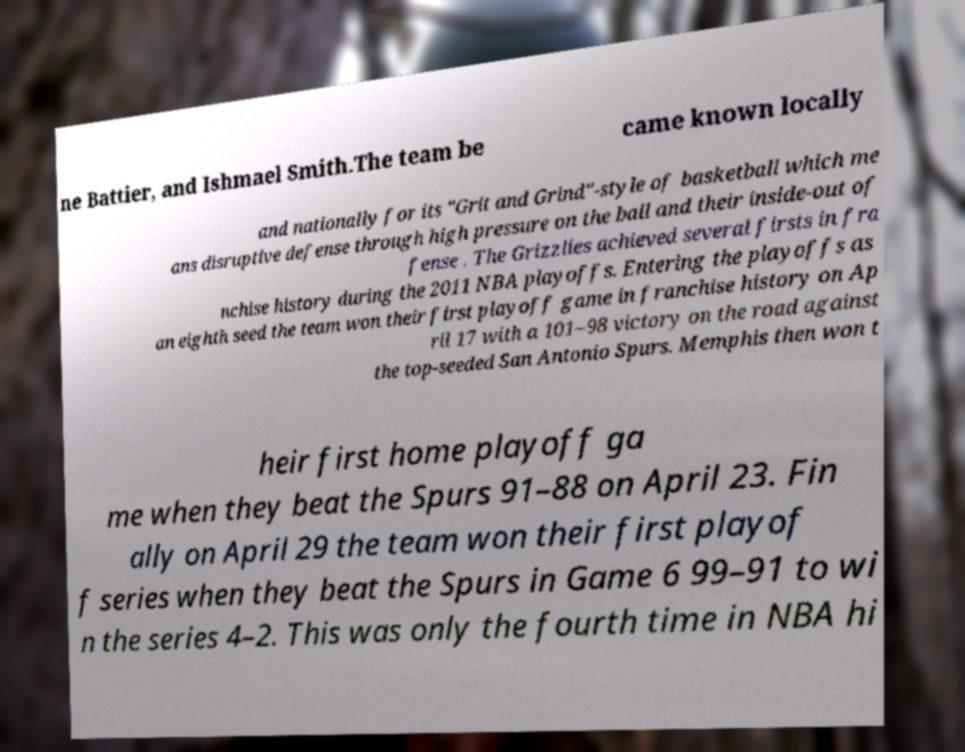Can you accurately transcribe the text from the provided image for me? ne Battier, and Ishmael Smith.The team be came known locally and nationally for its "Grit and Grind"-style of basketball which me ans disruptive defense through high pressure on the ball and their inside-out of fense . The Grizzlies achieved several firsts in fra nchise history during the 2011 NBA playoffs. Entering the playoffs as an eighth seed the team won their first playoff game in franchise history on Ap ril 17 with a 101–98 victory on the road against the top-seeded San Antonio Spurs. Memphis then won t heir first home playoff ga me when they beat the Spurs 91–88 on April 23. Fin ally on April 29 the team won their first playof f series when they beat the Spurs in Game 6 99–91 to wi n the series 4–2. This was only the fourth time in NBA hi 